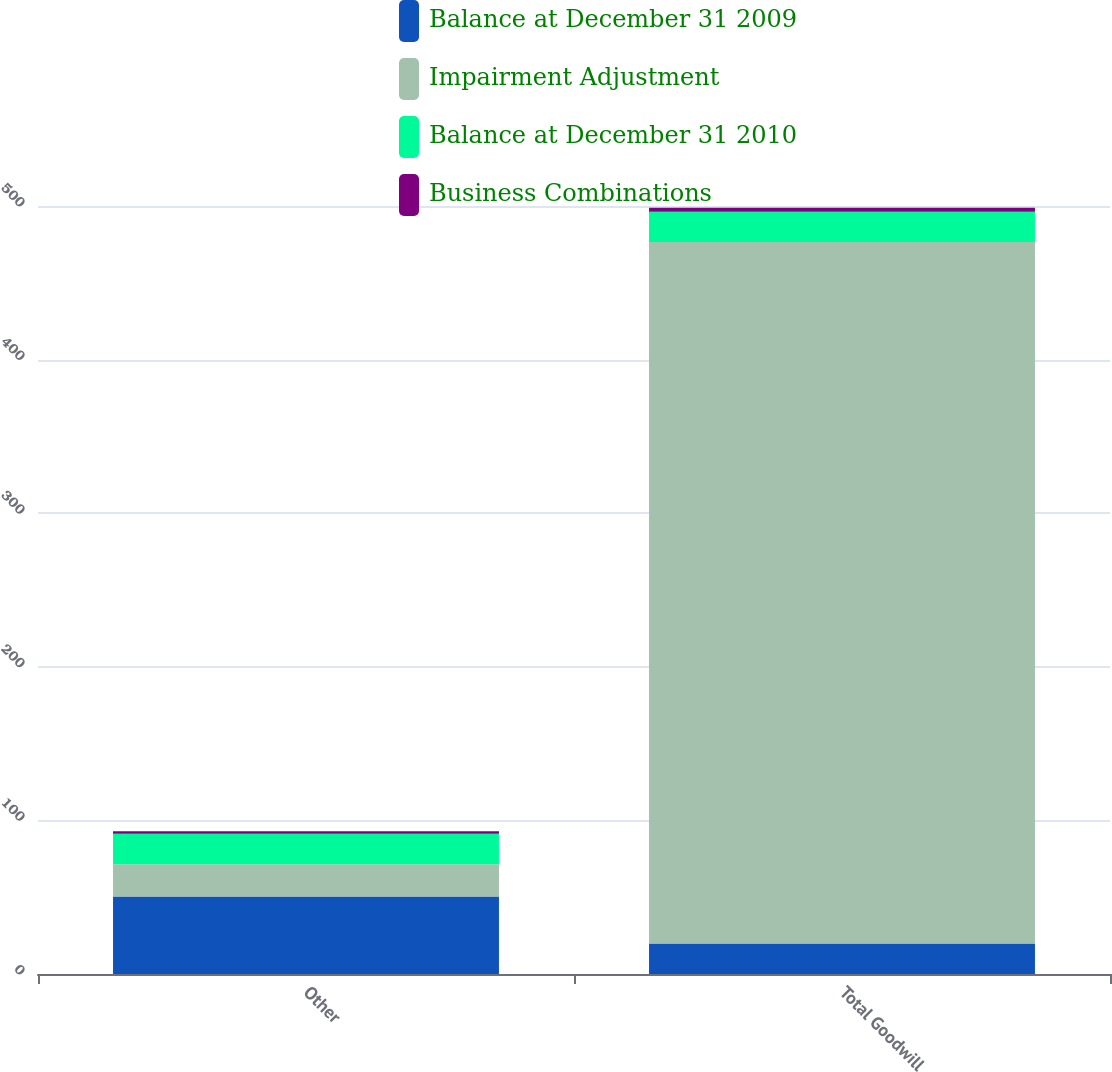<chart> <loc_0><loc_0><loc_500><loc_500><stacked_bar_chart><ecel><fcel>Other<fcel>Total Goodwill<nl><fcel>Balance at December 31 2009<fcel>50.4<fcel>19.8<nl><fcel>Impairment Adjustment<fcel>21.1<fcel>456.7<nl><fcel>Balance at December 31 2010<fcel>19.8<fcel>19.8<nl><fcel>Business Combinations<fcel>1.7<fcel>2.5<nl></chart> 